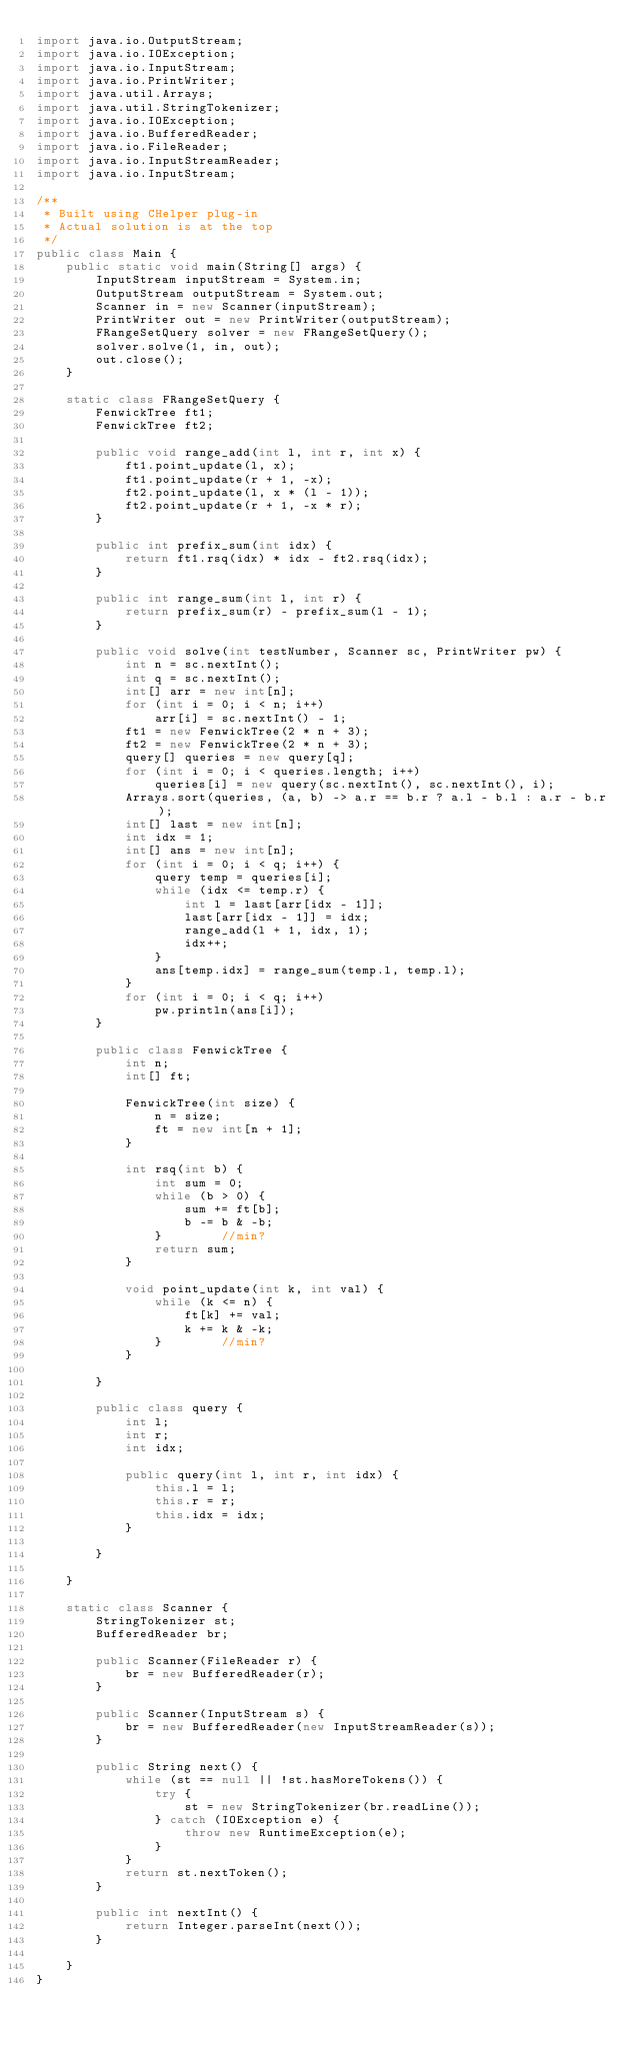Convert code to text. <code><loc_0><loc_0><loc_500><loc_500><_Java_>import java.io.OutputStream;
import java.io.IOException;
import java.io.InputStream;
import java.io.PrintWriter;
import java.util.Arrays;
import java.util.StringTokenizer;
import java.io.IOException;
import java.io.BufferedReader;
import java.io.FileReader;
import java.io.InputStreamReader;
import java.io.InputStream;

/**
 * Built using CHelper plug-in
 * Actual solution is at the top
 */
public class Main {
    public static void main(String[] args) {
        InputStream inputStream = System.in;
        OutputStream outputStream = System.out;
        Scanner in = new Scanner(inputStream);
        PrintWriter out = new PrintWriter(outputStream);
        FRangeSetQuery solver = new FRangeSetQuery();
        solver.solve(1, in, out);
        out.close();
    }

    static class FRangeSetQuery {
        FenwickTree ft1;
        FenwickTree ft2;

        public void range_add(int l, int r, int x) {
            ft1.point_update(l, x);
            ft1.point_update(r + 1, -x);
            ft2.point_update(l, x * (l - 1));
            ft2.point_update(r + 1, -x * r);
        }

        public int prefix_sum(int idx) {
            return ft1.rsq(idx) * idx - ft2.rsq(idx);
        }

        public int range_sum(int l, int r) {
            return prefix_sum(r) - prefix_sum(l - 1);
        }

        public void solve(int testNumber, Scanner sc, PrintWriter pw) {
            int n = sc.nextInt();
            int q = sc.nextInt();
            int[] arr = new int[n];
            for (int i = 0; i < n; i++)
                arr[i] = sc.nextInt() - 1;
            ft1 = new FenwickTree(2 * n + 3);
            ft2 = new FenwickTree(2 * n + 3);
            query[] queries = new query[q];
            for (int i = 0; i < queries.length; i++)
                queries[i] = new query(sc.nextInt(), sc.nextInt(), i);
            Arrays.sort(queries, (a, b) -> a.r == b.r ? a.l - b.l : a.r - b.r);
            int[] last = new int[n];
            int idx = 1;
            int[] ans = new int[n];
            for (int i = 0; i < q; i++) {
                query temp = queries[i];
                while (idx <= temp.r) {
                    int l = last[arr[idx - 1]];
                    last[arr[idx - 1]] = idx;
                    range_add(l + 1, idx, 1);
                    idx++;
                }
                ans[temp.idx] = range_sum(temp.l, temp.l);
            }
            for (int i = 0; i < q; i++)
                pw.println(ans[i]);
        }

        public class FenwickTree {
            int n;
            int[] ft;

            FenwickTree(int size) {
                n = size;
                ft = new int[n + 1];
            }

            int rsq(int b) {
                int sum = 0;
                while (b > 0) {
                    sum += ft[b];
                    b -= b & -b;
                }        //min?
                return sum;
            }

            void point_update(int k, int val) {
                while (k <= n) {
                    ft[k] += val;
                    k += k & -k;
                }        //min?
            }

        }

        public class query {
            int l;
            int r;
            int idx;

            public query(int l, int r, int idx) {
                this.l = l;
                this.r = r;
                this.idx = idx;
            }

        }

    }

    static class Scanner {
        StringTokenizer st;
        BufferedReader br;

        public Scanner(FileReader r) {
            br = new BufferedReader(r);
        }

        public Scanner(InputStream s) {
            br = new BufferedReader(new InputStreamReader(s));
        }

        public String next() {
            while (st == null || !st.hasMoreTokens()) {
                try {
                    st = new StringTokenizer(br.readLine());
                } catch (IOException e) {
                    throw new RuntimeException(e);
                }
            }
            return st.nextToken();
        }

        public int nextInt() {
            return Integer.parseInt(next());
        }

    }
}

</code> 